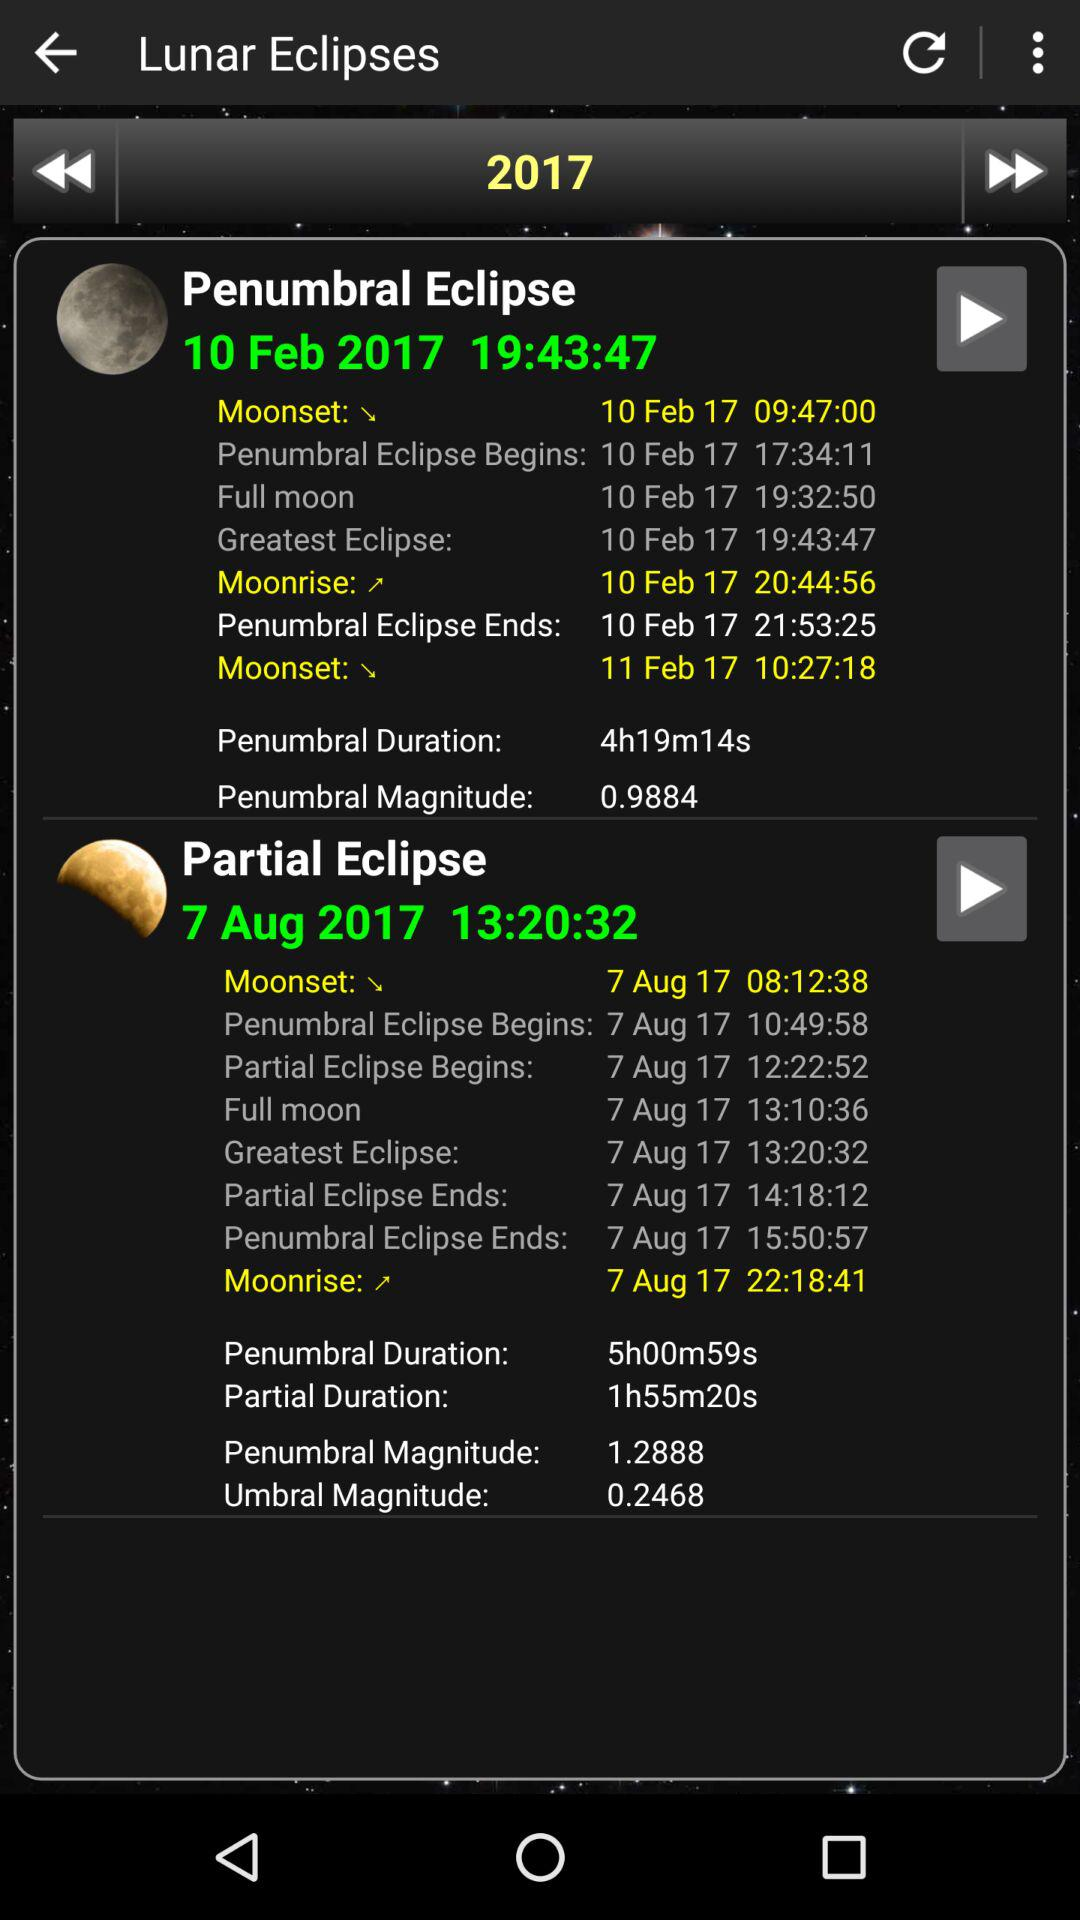What is the beginning time of the partial eclipse? The partial eclipse begins on August 7, 2017 at 12 hours, 22 minutes and 52 seconds. 